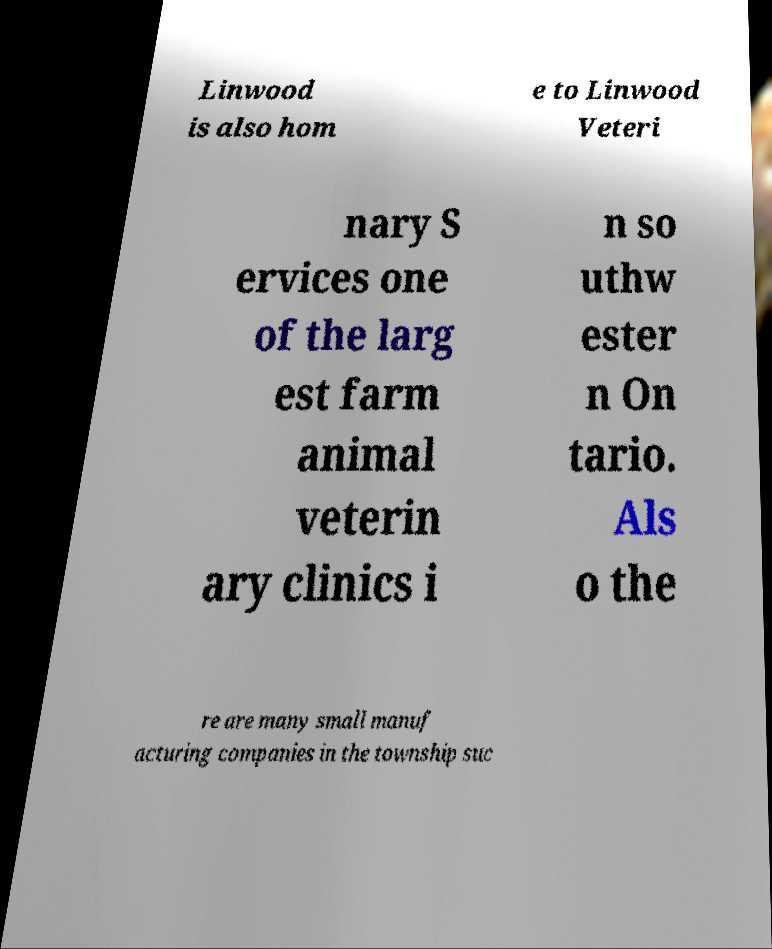Please read and relay the text visible in this image. What does it say? Linwood is also hom e to Linwood Veteri nary S ervices one of the larg est farm animal veterin ary clinics i n so uthw ester n On tario. Als o the re are many small manuf acturing companies in the township suc 